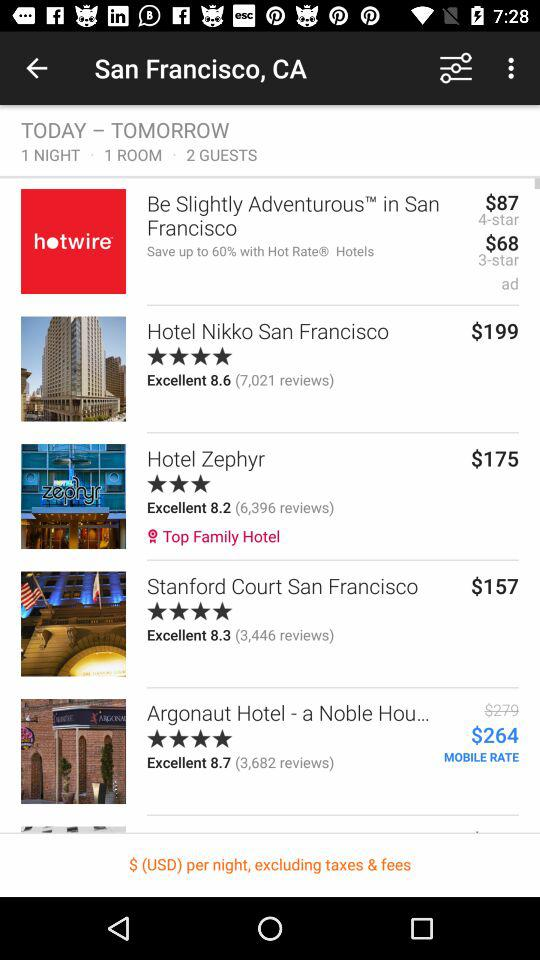What is the rating of "Hotel Zephyr"? The rating of "Hotel Zephyr" is 3 stars. 